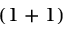<formula> <loc_0><loc_0><loc_500><loc_500>( 1 + 1 )</formula> 